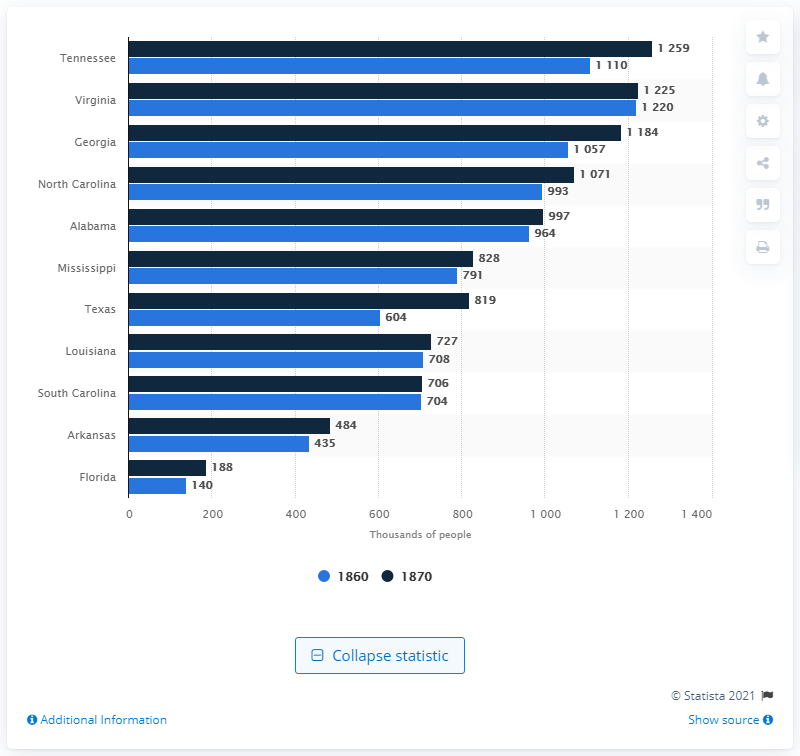Identify some key points in this picture. Texas experienced the largest amount of growth in the ten year period. 